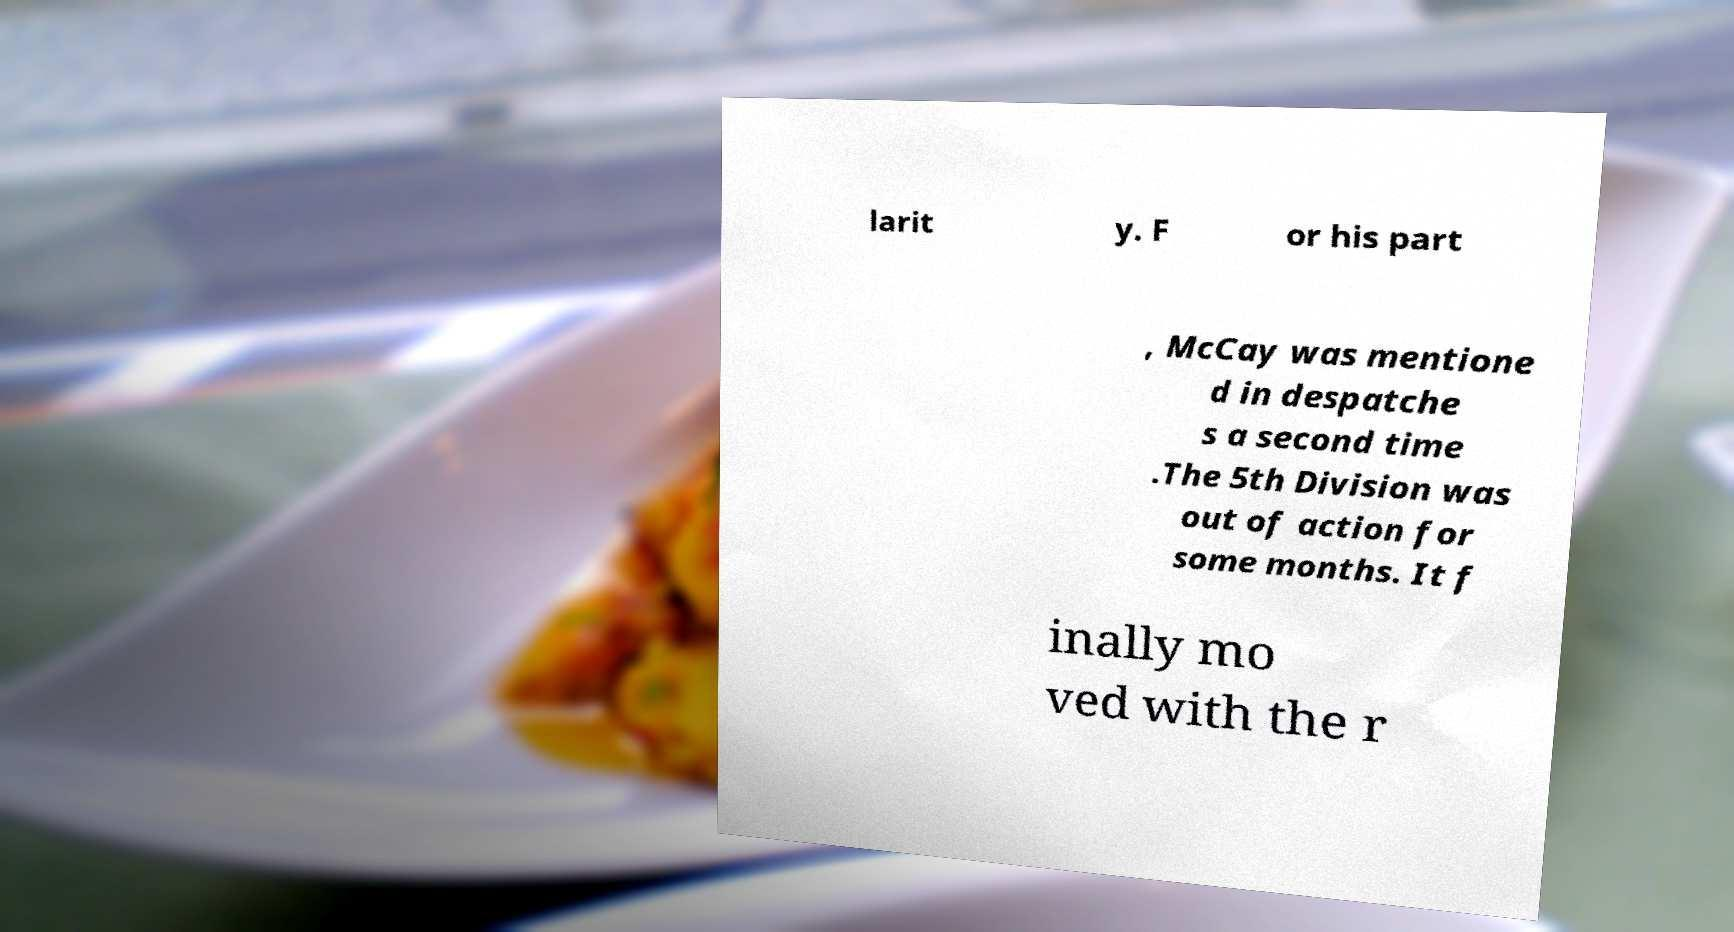I need the written content from this picture converted into text. Can you do that? larit y. F or his part , McCay was mentione d in despatche s a second time .The 5th Division was out of action for some months. It f inally mo ved with the r 